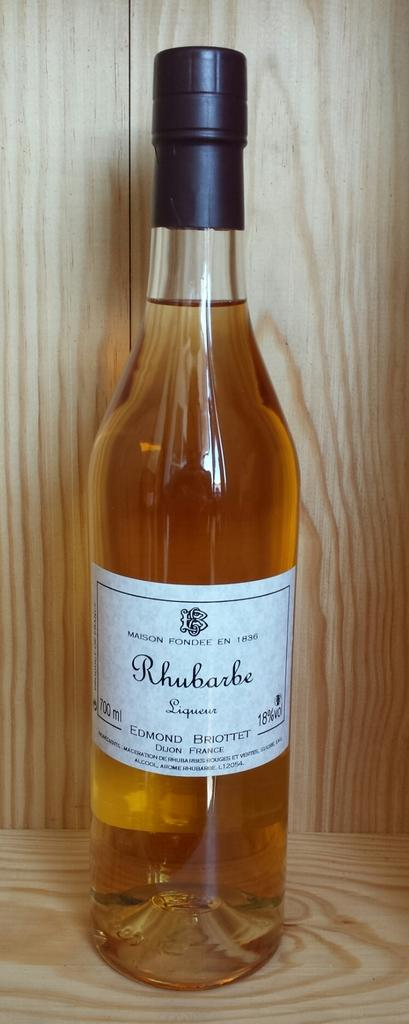Provide a one-sentence caption for the provided image. Rhubarb liqueur sits unopened on a wood surface. 